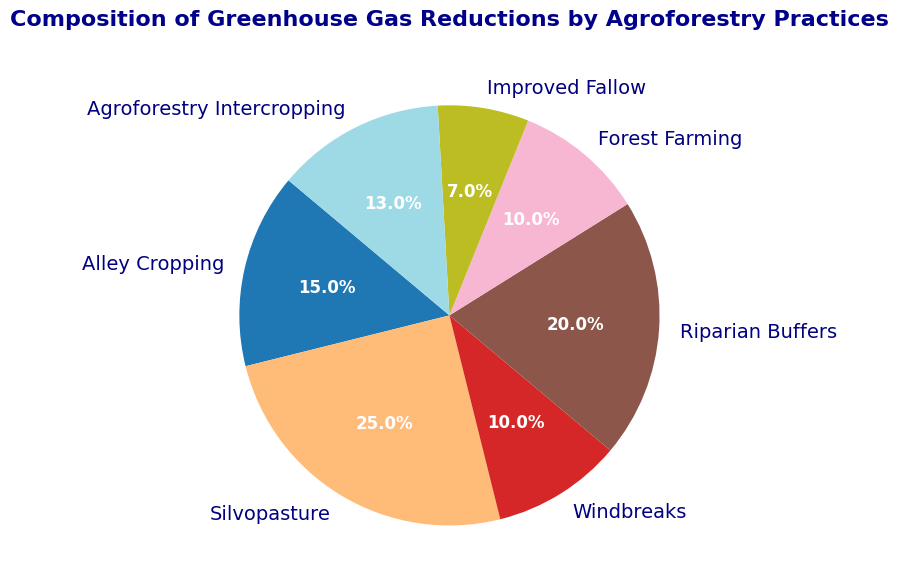Which agroforestry practice contributes the most to greenhouse gas reductions? Looking at the pie chart, the largest wedge corresponds to Silvopasture, which has the highest percentage at 25%.
Answer: Silvopasture What is the total percentage of greenhouse gas reductions contributed by Windbreaks and Forest Farming combined? The chart shows Windbreaks and Forest Farming contributing 10% each. Adding these together: 10% + 10% = 20%.
Answer: 20% Which practices have the same percentage reduction in greenhouse gases, and what is that percentage? The pie chart shows both Windbreaks and Forest Farming each have a wedge labeled with 10%.
Answer: Windbreaks and Forest Farming, 10% How much greater is the contribution of Silvopasture compared to Alley Cropping? Silvopasture contributes 25%, and Alley Cropping contributes 15%. The difference is 25% - 15% = 10%.
Answer: 10% Which practice contributes the least to greenhouse gas reductions, and what is its percentage? The smallest wedge in the pie chart corresponds to Improved Fallow, with a percentage label of 7%.
Answer: Improved Fallow, 7% What is the combined percentage for the three practices with the smallest contributions? Improved Fallow (7%), Windbreaks (10%), and Forest Farming (10%) are the smallest. Adding these: 7% + 10% + 10% = 27%.
Answer: 27% Is the contribution of Riparian Buffers higher or lower than the contribution of Agroforestry Intercropping? Riparian Buffers contribute 20%, while Agroforestry Intercropping contributes 13%, so Riparian Buffers' contribution is higher.
Answer: Higher Which colored section represents the practice that reduces greenhouse gases by 20%? The section labeled Riparian Buffers shows a 20% reduction. The Riparian Buffers section is colored in one of the shades provided by the 'tab20' colormap.
Answer: Riparian Buffers Rank the practices from highest to lowest in terms of their greenhouse gas reduction contributions. By observing the percentage values on the chart: Silvopasture (25%), Riparian Buffers (20%), Alley Cropping (15%), Agroforestry Intercropping (13%), Windbreaks (10%), Forest Farming (10%), Improved Fallow (7%).
Answer: Silvopasture, Riparian Buffers, Alley Cropping, Agroforestry Intercropping, Windbreaks, Forest Farming, Improved Fallow What percentage of the total greenhouse gas reductions is contributed by practices other than Silvopasture? Silvopasture contributes 25%, so the rest is 100% - 25% = 75%.
Answer: 75% 